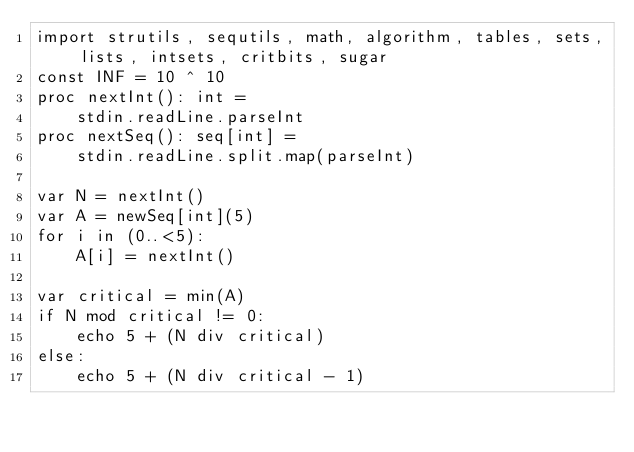Convert code to text. <code><loc_0><loc_0><loc_500><loc_500><_Nim_>import strutils, sequtils, math, algorithm, tables, sets, lists, intsets, critbits, sugar
const INF = 10 ^ 10
proc nextInt(): int =
    stdin.readLine.parseInt
proc nextSeq(): seq[int] =
    stdin.readLine.split.map(parseInt)

var N = nextInt()
var A = newSeq[int](5)
for i in (0..<5):
    A[i] = nextInt()

var critical = min(A)
if N mod critical != 0:
    echo 5 + (N div critical)
else:
    echo 5 + (N div critical - 1)</code> 